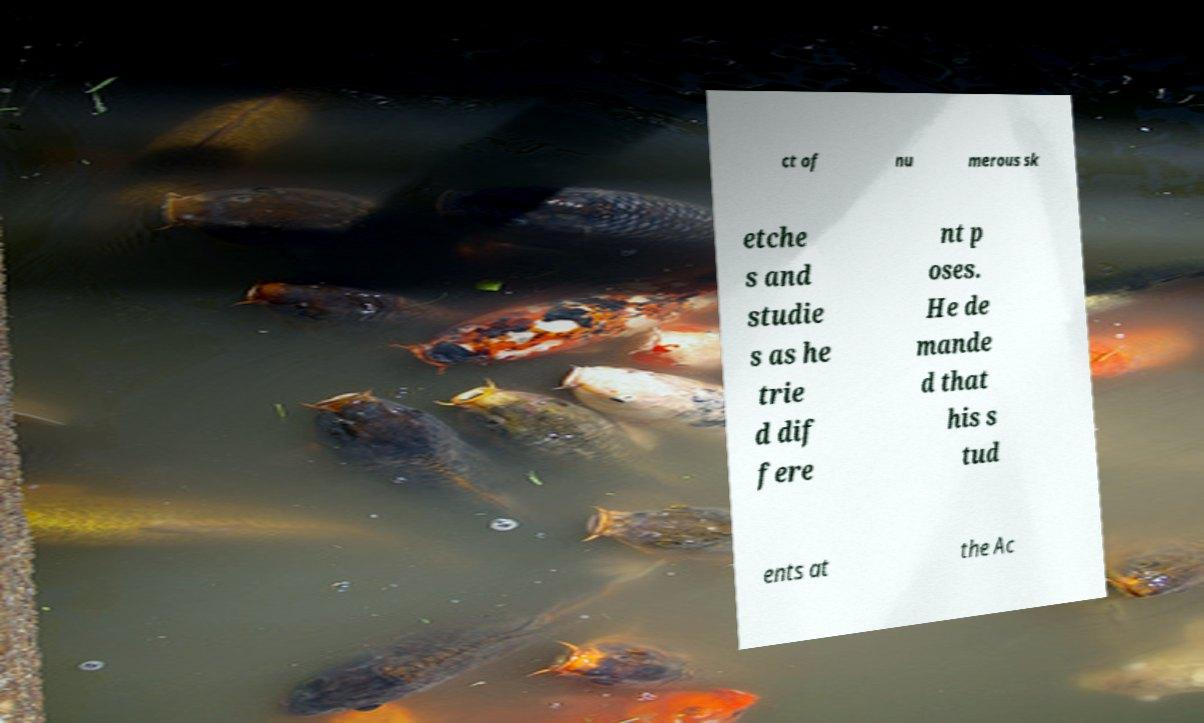Can you accurately transcribe the text from the provided image for me? ct of nu merous sk etche s and studie s as he trie d dif fere nt p oses. He de mande d that his s tud ents at the Ac 